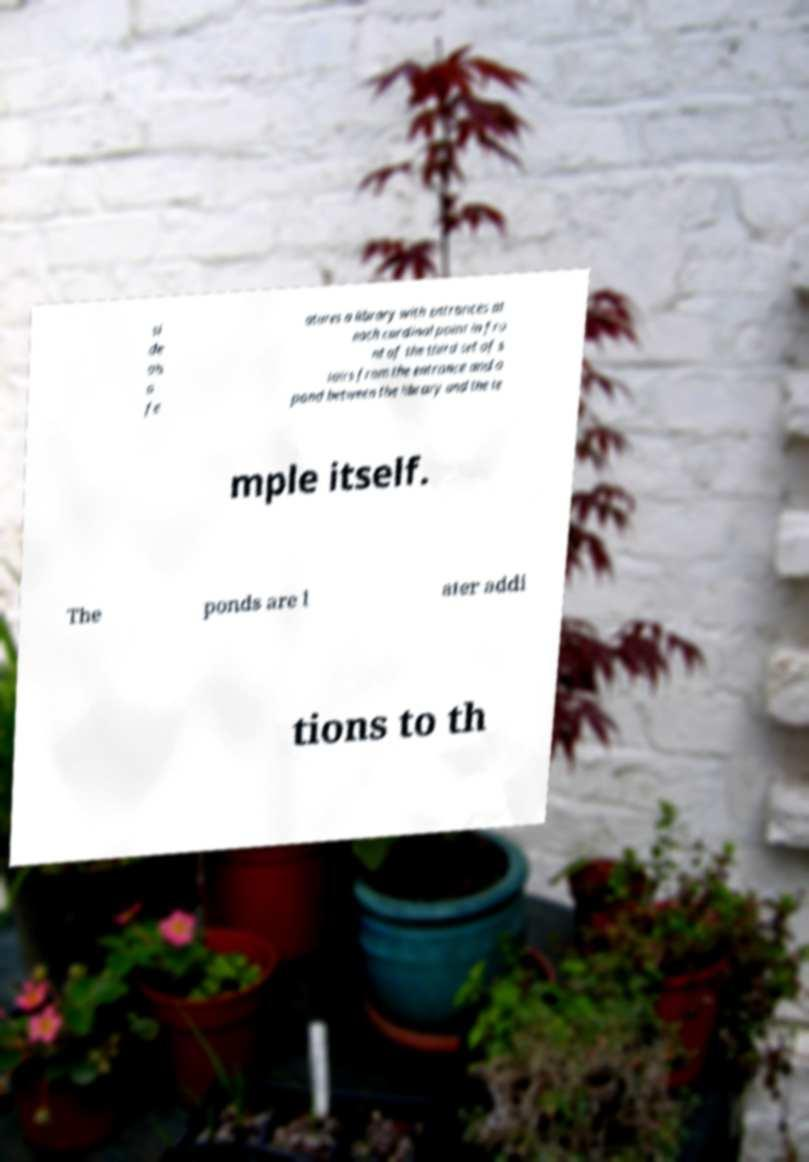For documentation purposes, I need the text within this image transcribed. Could you provide that? si de als o fe atures a library with entrances at each cardinal point in fro nt of the third set of s tairs from the entrance and a pond between the library and the te mple itself. The ponds are l ater addi tions to th 